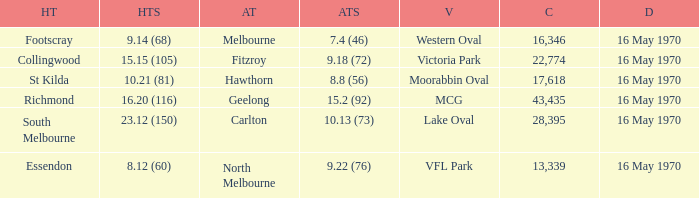What did the away team score when the home team was south melbourne? 10.13 (73). 